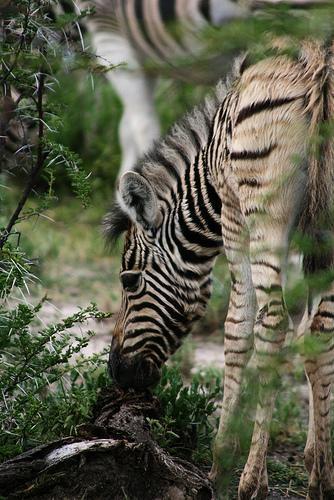How many zebras are there?
Give a very brief answer. 1. 